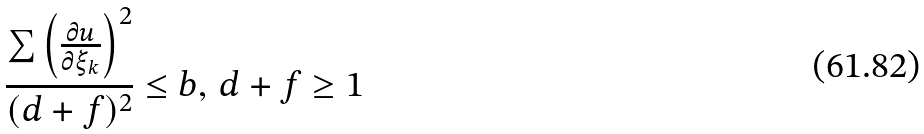<formula> <loc_0><loc_0><loc_500><loc_500>\frac { \sum \left ( \frac { \partial u } { \partial \xi _ { k } } \right ) ^ { 2 } } { ( d + f ) ^ { 2 } } \leq b , \, d + f \geq 1</formula> 